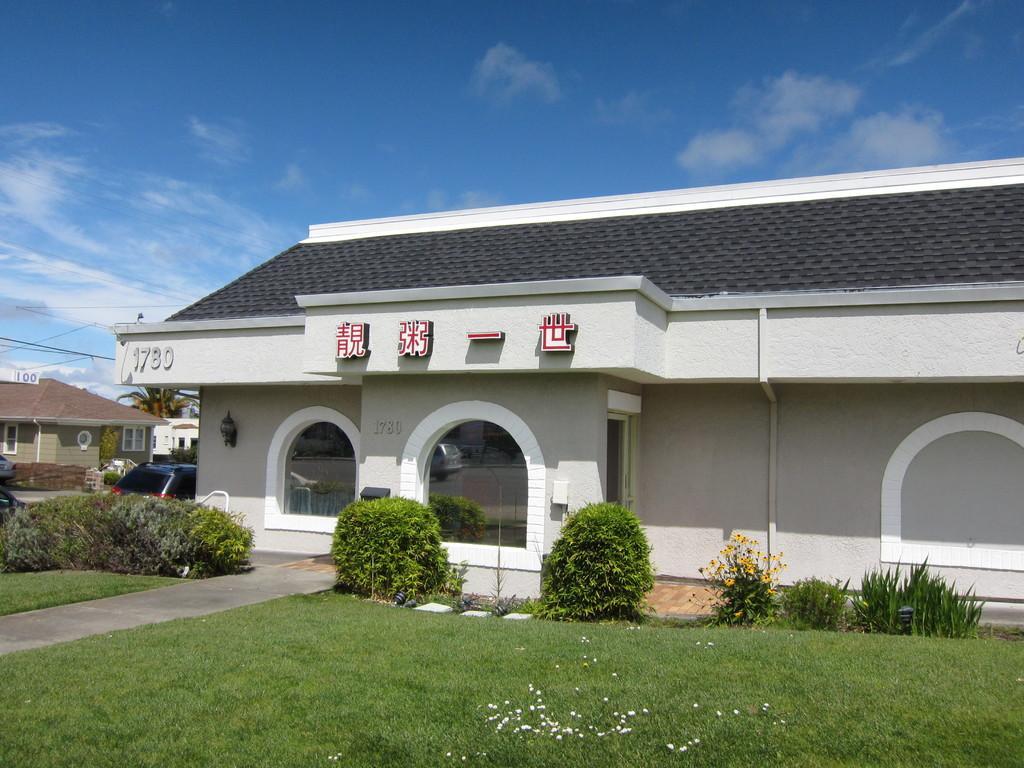Could you give a brief overview of what you see in this image? In the image we can see there is a building and its written ¨1780¨ on the building. There are plants and bushes on the ground. The ground is covered with grass and there is a car parked on the road. Behind there are buildings and there is a cloudy sky. 